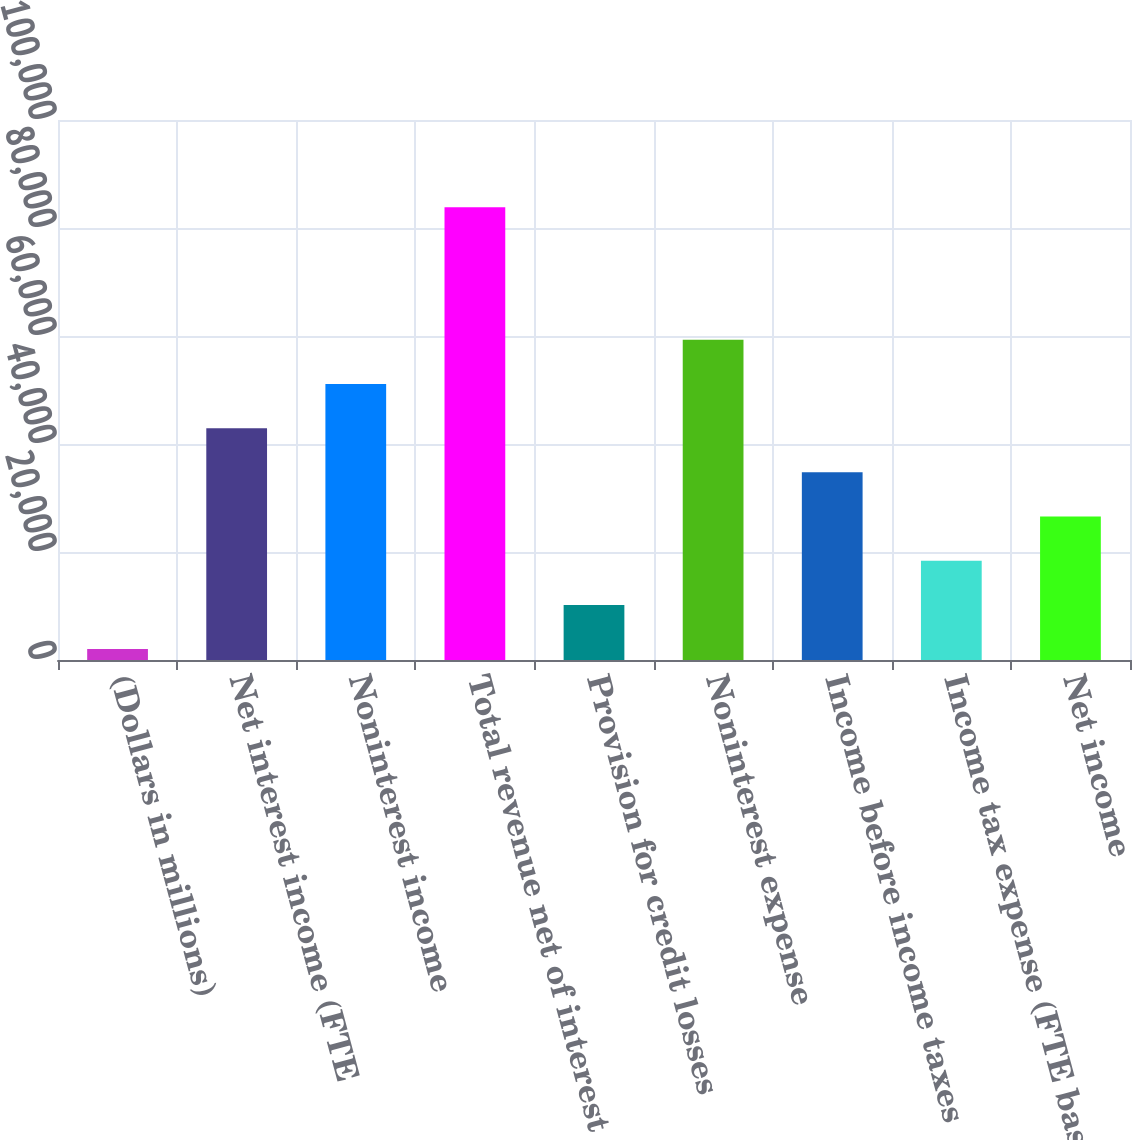Convert chart. <chart><loc_0><loc_0><loc_500><loc_500><bar_chart><fcel>(Dollars in millions)<fcel>Net interest income (FTE<fcel>Noninterest income<fcel>Total revenue net of interest<fcel>Provision for credit losses<fcel>Noninterest expense<fcel>Income before income taxes<fcel>Income tax expense (FTE basis)<fcel>Net income<nl><fcel>2015<fcel>42934.5<fcel>51118.4<fcel>83854<fcel>10198.9<fcel>59302.3<fcel>34750.6<fcel>18382.8<fcel>26566.7<nl></chart> 